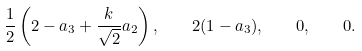Convert formula to latex. <formula><loc_0><loc_0><loc_500><loc_500>\frac { 1 } { 2 } \left ( 2 - a _ { 3 } + \frac { k } { \sqrt { 2 } } a _ { 2 } \right ) , \quad 2 ( 1 - a _ { 3 } ) , \quad 0 , \quad 0 .</formula> 